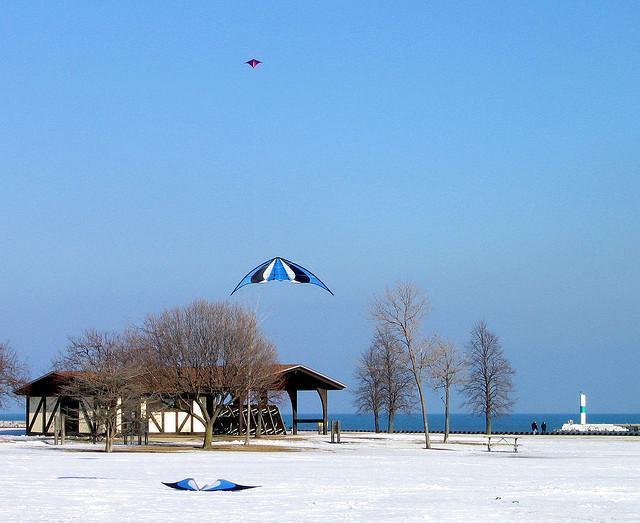How many drinks cups have straw?
Give a very brief answer. 0. 